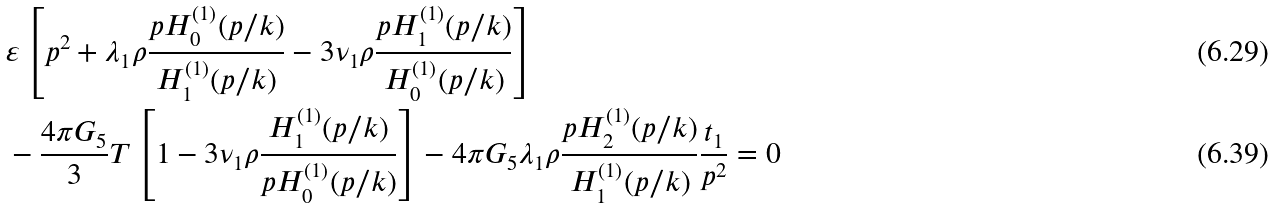Convert formula to latex. <formula><loc_0><loc_0><loc_500><loc_500>& \varepsilon \left [ p ^ { 2 } + \lambda _ { 1 } \rho \frac { p H _ { 0 } ^ { ( 1 ) } ( p / k ) } { H _ { 1 } ^ { ( 1 ) } ( p / k ) } - 3 \nu _ { 1 } \rho \frac { p H _ { 1 } ^ { ( 1 ) } ( p / k ) } { H _ { 0 } ^ { ( 1 ) } ( p / k ) } \right ] \\ & - \frac { 4 \pi G _ { 5 } } { 3 } T \left [ 1 - 3 \nu _ { 1 } \rho \frac { H _ { 1 } ^ { ( 1 ) } ( p / k ) } { p H _ { 0 } ^ { ( 1 ) } ( p / k ) } \right ] - 4 \pi G _ { 5 } \lambda _ { 1 } \rho \frac { p H _ { 2 } ^ { ( 1 ) } ( p / k ) } { H _ { 1 } ^ { ( 1 ) } ( p / k ) } \frac { t _ { 1 } } { { p } ^ { 2 } } = 0</formula> 